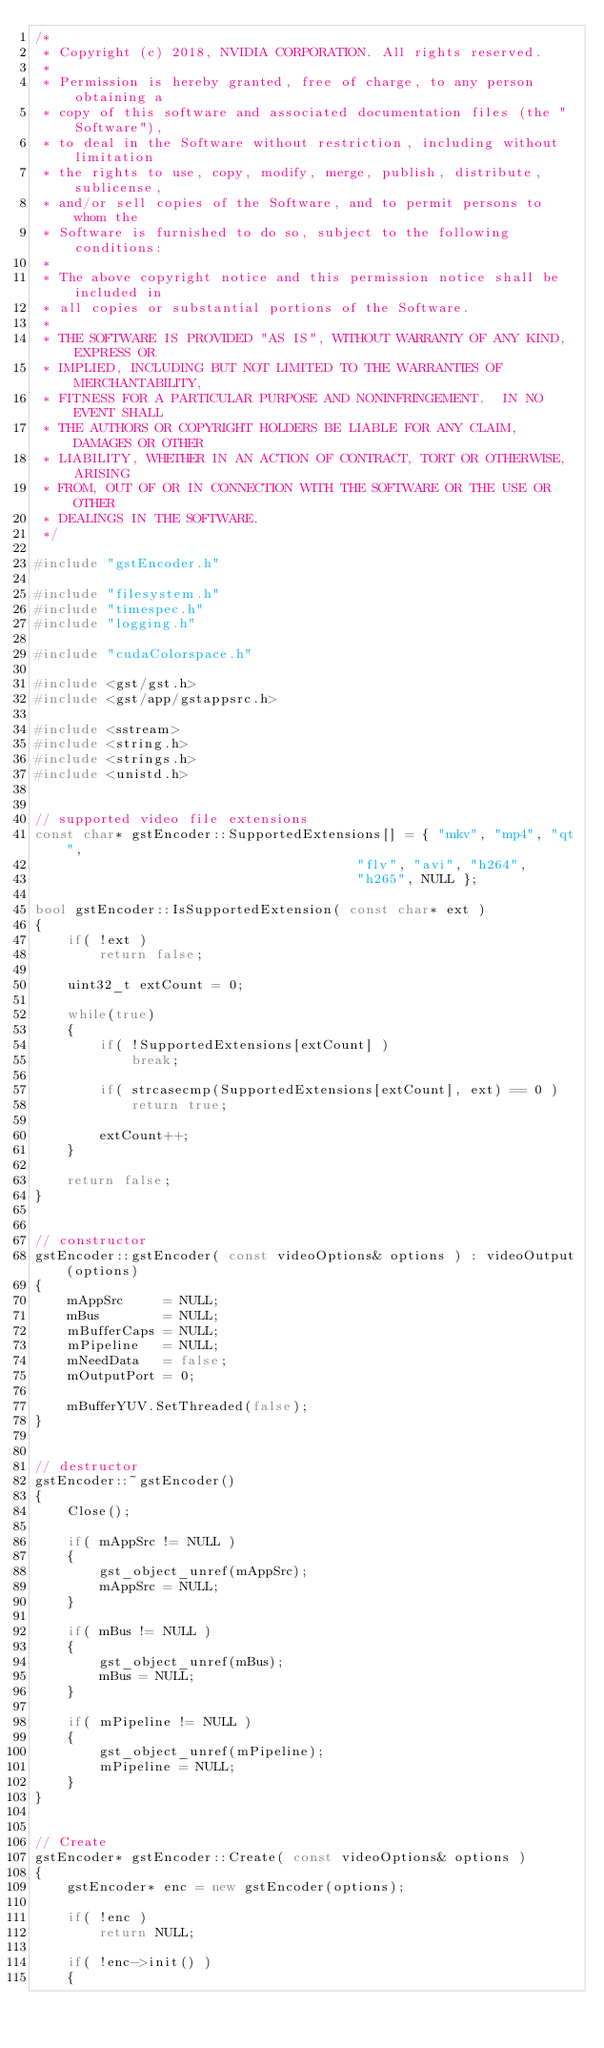<code> <loc_0><loc_0><loc_500><loc_500><_C++_>/*
 * Copyright (c) 2018, NVIDIA CORPORATION. All rights reserved.
 *
 * Permission is hereby granted, free of charge, to any person obtaining a
 * copy of this software and associated documentation files (the "Software"),
 * to deal in the Software without restriction, including without limitation
 * the rights to use, copy, modify, merge, publish, distribute, sublicense,
 * and/or sell copies of the Software, and to permit persons to whom the
 * Software is furnished to do so, subject to the following conditions:
 *
 * The above copyright notice and this permission notice shall be included in
 * all copies or substantial portions of the Software.
 *
 * THE SOFTWARE IS PROVIDED "AS IS", WITHOUT WARRANTY OF ANY KIND, EXPRESS OR
 * IMPLIED, INCLUDING BUT NOT LIMITED TO THE WARRANTIES OF MERCHANTABILITY,
 * FITNESS FOR A PARTICULAR PURPOSE AND NONINFRINGEMENT.  IN NO EVENT SHALL
 * THE AUTHORS OR COPYRIGHT HOLDERS BE LIABLE FOR ANY CLAIM, DAMAGES OR OTHER
 * LIABILITY, WHETHER IN AN ACTION OF CONTRACT, TORT OR OTHERWISE, ARISING
 * FROM, OUT OF OR IN CONNECTION WITH THE SOFTWARE OR THE USE OR OTHER
 * DEALINGS IN THE SOFTWARE.
 */

#include "gstEncoder.h"

#include "filesystem.h"
#include "timespec.h"
#include "logging.h"

#include "cudaColorspace.h"

#include <gst/gst.h>
#include <gst/app/gstappsrc.h>

#include <sstream>
#include <string.h>
#include <strings.h>
#include <unistd.h>


// supported video file extensions
const char* gstEncoder::SupportedExtensions[] = { "mkv", "mp4", "qt", 
										"flv", "avi", "h264", 
										"h265", NULL };

bool gstEncoder::IsSupportedExtension( const char* ext )
{
	if( !ext )
		return false;

	uint32_t extCount = 0;

	while(true)
	{
		if( !SupportedExtensions[extCount] )
			break;

		if( strcasecmp(SupportedExtensions[extCount], ext) == 0 )
			return true;

		extCount++;
	}

	return false;
}


// constructor
gstEncoder::gstEncoder( const videoOptions& options ) : videoOutput(options)
{	
	mAppSrc     = NULL;
	mBus        = NULL;
	mBufferCaps = NULL;
	mPipeline   = NULL;
	mNeedData   = false;
	mOutputPort = 0;

	mBufferYUV.SetThreaded(false);
}


// destructor	
gstEncoder::~gstEncoder()
{
	Close();

	if( mAppSrc != NULL )
	{
		gst_object_unref(mAppSrc);
		mAppSrc = NULL;
	}

	if( mBus != NULL )
	{
		gst_object_unref(mBus);
		mBus = NULL;
	}

	if( mPipeline != NULL )
	{
		gst_object_unref(mPipeline);
		mPipeline = NULL;
	}
}


// Create
gstEncoder* gstEncoder::Create( const videoOptions& options )
{
	gstEncoder* enc = new gstEncoder(options);
	
	if( !enc )
		return NULL;
	
	if( !enc->init() )
	{</code> 